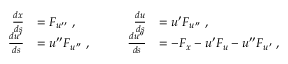Convert formula to latex. <formula><loc_0><loc_0><loc_500><loc_500>\begin{array} { r l r l } { \frac { d x } { d s } } & { = F _ { u ^ { \prime \prime } } \, , } & { \frac { d u } { d s } } & { = u ^ { \prime } F _ { u ^ { \prime \prime } } \, , } \\ { \frac { d u ^ { \prime } } { d s } } & { = u ^ { \prime \prime } F _ { u ^ { \prime \prime } } \, , \quad } & { \frac { d u ^ { \prime \prime } } { d s } } & { = - F _ { x } - u ^ { \prime } F _ { u } - u ^ { \prime \prime } F _ { u ^ { \prime } } \, , } \end{array}</formula> 